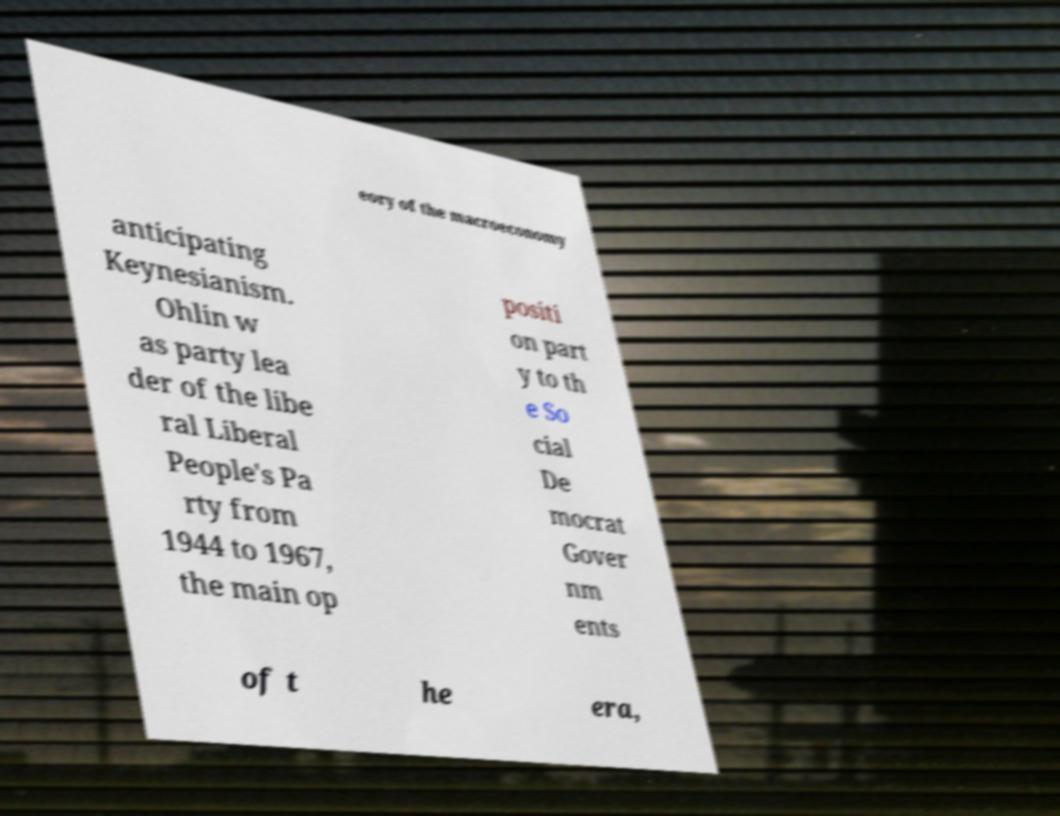Can you accurately transcribe the text from the provided image for me? eory of the macroeconomy anticipating Keynesianism. Ohlin w as party lea der of the libe ral Liberal People's Pa rty from 1944 to 1967, the main op positi on part y to th e So cial De mocrat Gover nm ents of t he era, 